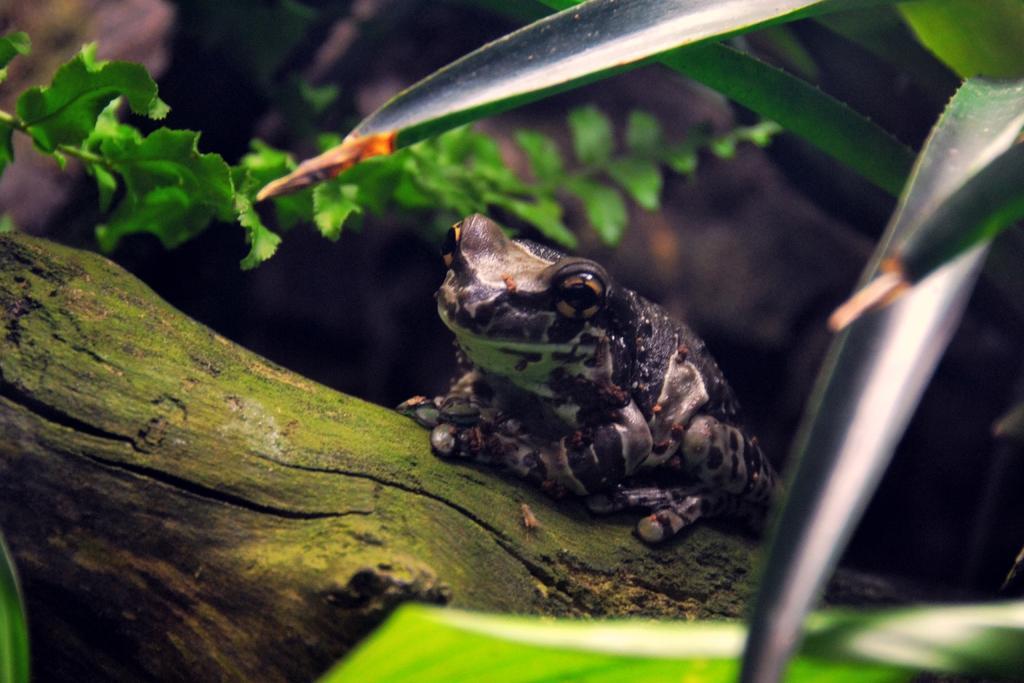Describe this image in one or two sentences. In this picture I can see there is a frog sitting on the tree trunk and there are leaves. 